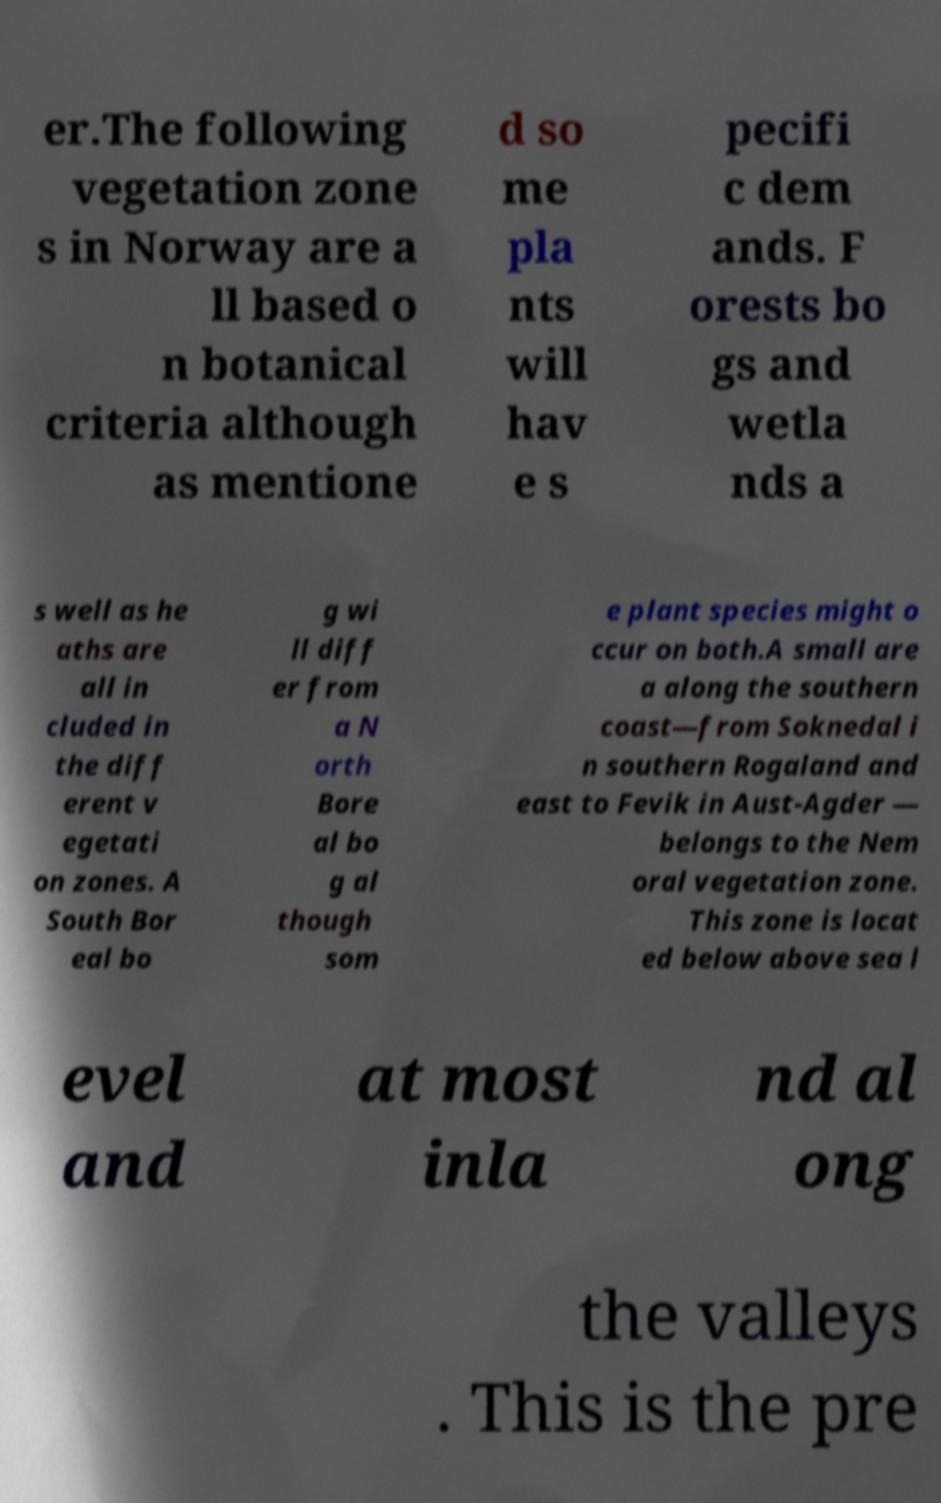Could you extract and type out the text from this image? er.The following vegetation zone s in Norway are a ll based o n botanical criteria although as mentione d so me pla nts will hav e s pecifi c dem ands. F orests bo gs and wetla nds a s well as he aths are all in cluded in the diff erent v egetati on zones. A South Bor eal bo g wi ll diff er from a N orth Bore al bo g al though som e plant species might o ccur on both.A small are a along the southern coast—from Soknedal i n southern Rogaland and east to Fevik in Aust-Agder — belongs to the Nem oral vegetation zone. This zone is locat ed below above sea l evel and at most inla nd al ong the valleys . This is the pre 